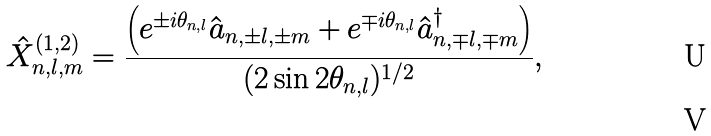<formula> <loc_0><loc_0><loc_500><loc_500>\hat { X } _ { n , l , m } ^ { ( 1 , 2 ) } = \frac { \left ( e ^ { \pm i \theta _ { n , l } } \hat { a } _ { n , \pm l , \pm m } + e ^ { \mp i \theta _ { n , l } } \hat { a } _ { n , \mp l , \mp m } ^ { \dag } \right ) } { ( 2 \sin 2 \theta _ { n , l } ) ^ { 1 / 2 } } , \\</formula> 